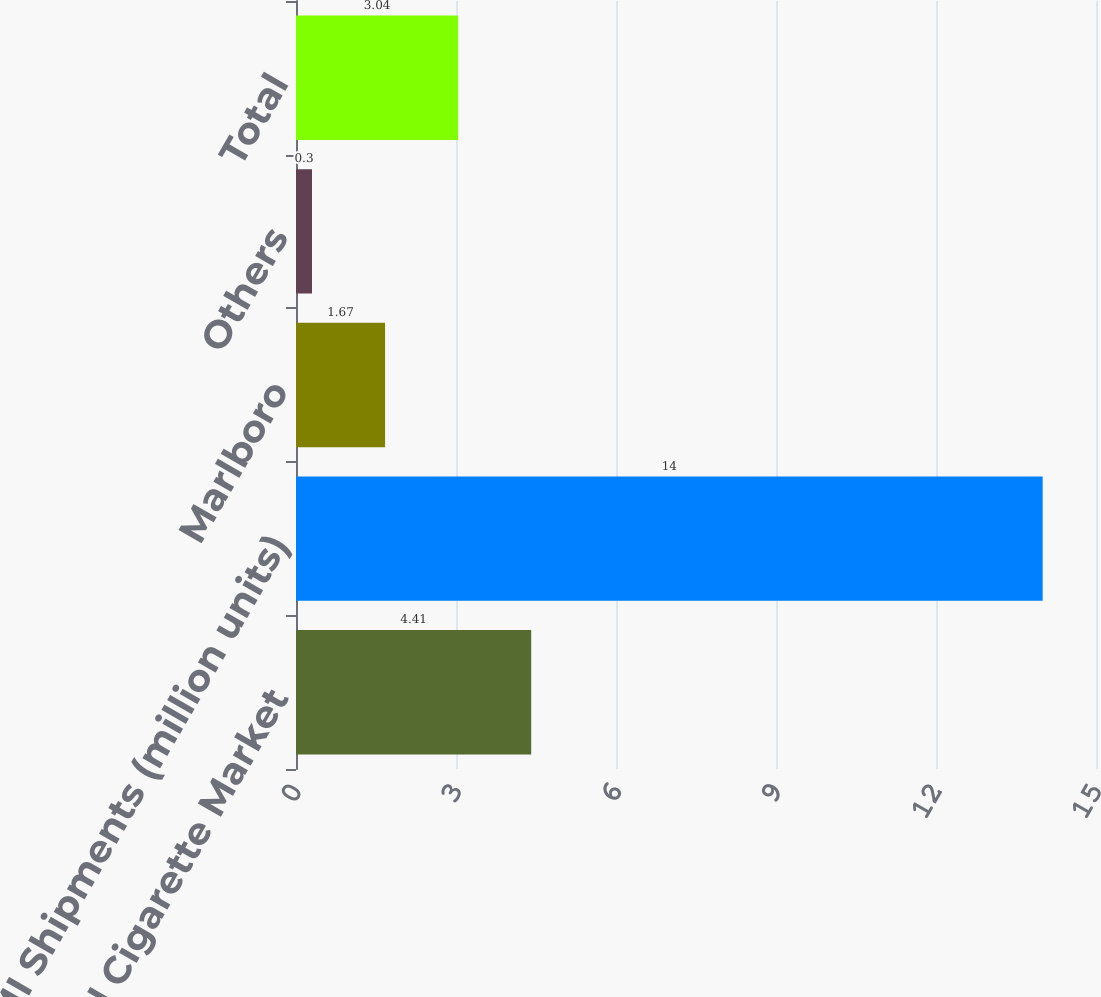Convert chart. <chart><loc_0><loc_0><loc_500><loc_500><bar_chart><fcel>Total Cigarette Market<fcel>PMI Shipments (million units)<fcel>Marlboro<fcel>Others<fcel>Total<nl><fcel>4.41<fcel>14<fcel>1.67<fcel>0.3<fcel>3.04<nl></chart> 